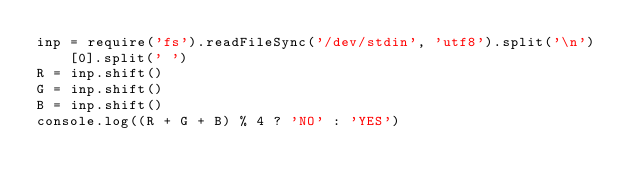<code> <loc_0><loc_0><loc_500><loc_500><_JavaScript_>inp = require('fs').readFileSync('/dev/stdin', 'utf8').split('\n')[0].split(' ')
R = inp.shift()
G = inp.shift()
B = inp.shift()
console.log((R + G + B) % 4 ? 'NO' : 'YES')</code> 